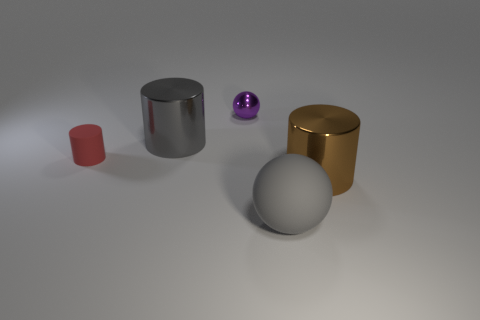How many large gray objects are the same material as the red thing?
Provide a short and direct response. 1. Are there fewer tiny red objects right of the metallic ball than big blue cylinders?
Provide a succinct answer. No. What is the size of the shiny cylinder that is on the right side of the shiny cylinder that is to the left of the shiny sphere?
Offer a very short reply. Large. Is the color of the small shiny sphere the same as the big cylinder that is left of the large brown metal cylinder?
Your answer should be compact. No. There is a sphere that is the same size as the red thing; what material is it?
Make the answer very short. Metal. Is the number of tiny spheres in front of the brown metallic thing less than the number of purple metal objects that are in front of the gray ball?
Keep it short and to the point. No. There is a big gray thing in front of the big object that is to the left of the tiny purple shiny object; what shape is it?
Provide a succinct answer. Sphere. Are any big red blocks visible?
Give a very brief answer. No. There is a cylinder that is right of the gray cylinder; what is its color?
Provide a succinct answer. Brown. There is a cylinder that is the same color as the large sphere; what is it made of?
Give a very brief answer. Metal. 